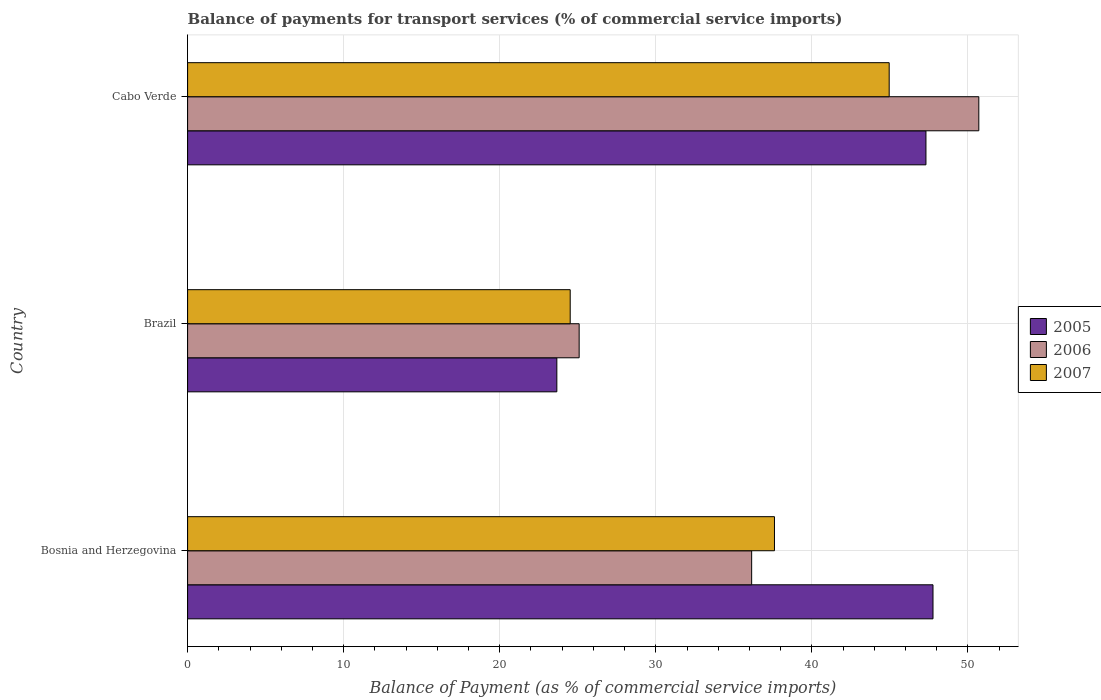How many different coloured bars are there?
Offer a very short reply. 3. Are the number of bars per tick equal to the number of legend labels?
Ensure brevity in your answer.  Yes. How many bars are there on the 2nd tick from the top?
Provide a succinct answer. 3. How many bars are there on the 1st tick from the bottom?
Keep it short and to the point. 3. What is the balance of payments for transport services in 2006 in Cabo Verde?
Provide a succinct answer. 50.7. Across all countries, what is the maximum balance of payments for transport services in 2005?
Give a very brief answer. 47.76. Across all countries, what is the minimum balance of payments for transport services in 2006?
Ensure brevity in your answer.  25.09. In which country was the balance of payments for transport services in 2006 maximum?
Keep it short and to the point. Cabo Verde. What is the total balance of payments for transport services in 2006 in the graph?
Your answer should be compact. 111.93. What is the difference between the balance of payments for transport services in 2006 in Brazil and that in Cabo Verde?
Your response must be concise. -25.61. What is the difference between the balance of payments for transport services in 2005 in Cabo Verde and the balance of payments for transport services in 2006 in Brazil?
Your answer should be compact. 22.22. What is the average balance of payments for transport services in 2007 per country?
Your answer should be compact. 35.69. What is the difference between the balance of payments for transport services in 2005 and balance of payments for transport services in 2006 in Bosnia and Herzegovina?
Your answer should be compact. 11.62. In how many countries, is the balance of payments for transport services in 2007 greater than 28 %?
Your answer should be very brief. 2. What is the ratio of the balance of payments for transport services in 2006 in Bosnia and Herzegovina to that in Cabo Verde?
Keep it short and to the point. 0.71. Is the balance of payments for transport services in 2006 in Bosnia and Herzegovina less than that in Cabo Verde?
Offer a very short reply. Yes. What is the difference between the highest and the second highest balance of payments for transport services in 2005?
Your answer should be compact. 0.45. What is the difference between the highest and the lowest balance of payments for transport services in 2006?
Offer a very short reply. 25.61. Is the sum of the balance of payments for transport services in 2005 in Brazil and Cabo Verde greater than the maximum balance of payments for transport services in 2006 across all countries?
Your answer should be compact. Yes. What does the 3rd bar from the top in Bosnia and Herzegovina represents?
Provide a succinct answer. 2005. What does the 1st bar from the bottom in Cabo Verde represents?
Keep it short and to the point. 2005. How many bars are there?
Your answer should be compact. 9. How many countries are there in the graph?
Offer a terse response. 3. Are the values on the major ticks of X-axis written in scientific E-notation?
Provide a short and direct response. No. Does the graph contain grids?
Ensure brevity in your answer.  Yes. Where does the legend appear in the graph?
Your answer should be compact. Center right. How many legend labels are there?
Provide a short and direct response. 3. How are the legend labels stacked?
Your answer should be compact. Vertical. What is the title of the graph?
Keep it short and to the point. Balance of payments for transport services (% of commercial service imports). Does "1968" appear as one of the legend labels in the graph?
Offer a terse response. No. What is the label or title of the X-axis?
Ensure brevity in your answer.  Balance of Payment (as % of commercial service imports). What is the label or title of the Y-axis?
Provide a short and direct response. Country. What is the Balance of Payment (as % of commercial service imports) of 2005 in Bosnia and Herzegovina?
Make the answer very short. 47.76. What is the Balance of Payment (as % of commercial service imports) in 2006 in Bosnia and Herzegovina?
Provide a succinct answer. 36.14. What is the Balance of Payment (as % of commercial service imports) in 2007 in Bosnia and Herzegovina?
Your answer should be very brief. 37.6. What is the Balance of Payment (as % of commercial service imports) in 2005 in Brazil?
Provide a succinct answer. 23.66. What is the Balance of Payment (as % of commercial service imports) of 2006 in Brazil?
Your response must be concise. 25.09. What is the Balance of Payment (as % of commercial service imports) in 2007 in Brazil?
Your answer should be very brief. 24.52. What is the Balance of Payment (as % of commercial service imports) in 2005 in Cabo Verde?
Ensure brevity in your answer.  47.31. What is the Balance of Payment (as % of commercial service imports) of 2006 in Cabo Verde?
Give a very brief answer. 50.7. What is the Balance of Payment (as % of commercial service imports) in 2007 in Cabo Verde?
Provide a short and direct response. 44.96. Across all countries, what is the maximum Balance of Payment (as % of commercial service imports) of 2005?
Provide a short and direct response. 47.76. Across all countries, what is the maximum Balance of Payment (as % of commercial service imports) of 2006?
Provide a succinct answer. 50.7. Across all countries, what is the maximum Balance of Payment (as % of commercial service imports) in 2007?
Your answer should be compact. 44.96. Across all countries, what is the minimum Balance of Payment (as % of commercial service imports) of 2005?
Give a very brief answer. 23.66. Across all countries, what is the minimum Balance of Payment (as % of commercial service imports) in 2006?
Your response must be concise. 25.09. Across all countries, what is the minimum Balance of Payment (as % of commercial service imports) of 2007?
Provide a succinct answer. 24.52. What is the total Balance of Payment (as % of commercial service imports) in 2005 in the graph?
Your answer should be compact. 118.73. What is the total Balance of Payment (as % of commercial service imports) of 2006 in the graph?
Your answer should be very brief. 111.93. What is the total Balance of Payment (as % of commercial service imports) of 2007 in the graph?
Your answer should be compact. 107.08. What is the difference between the Balance of Payment (as % of commercial service imports) in 2005 in Bosnia and Herzegovina and that in Brazil?
Your answer should be compact. 24.1. What is the difference between the Balance of Payment (as % of commercial service imports) of 2006 in Bosnia and Herzegovina and that in Brazil?
Ensure brevity in your answer.  11.05. What is the difference between the Balance of Payment (as % of commercial service imports) in 2007 in Bosnia and Herzegovina and that in Brazil?
Your answer should be very brief. 13.09. What is the difference between the Balance of Payment (as % of commercial service imports) in 2005 in Bosnia and Herzegovina and that in Cabo Verde?
Provide a succinct answer. 0.45. What is the difference between the Balance of Payment (as % of commercial service imports) of 2006 in Bosnia and Herzegovina and that in Cabo Verde?
Provide a short and direct response. -14.55. What is the difference between the Balance of Payment (as % of commercial service imports) in 2007 in Bosnia and Herzegovina and that in Cabo Verde?
Provide a short and direct response. -7.35. What is the difference between the Balance of Payment (as % of commercial service imports) in 2005 in Brazil and that in Cabo Verde?
Keep it short and to the point. -23.65. What is the difference between the Balance of Payment (as % of commercial service imports) in 2006 in Brazil and that in Cabo Verde?
Keep it short and to the point. -25.61. What is the difference between the Balance of Payment (as % of commercial service imports) of 2007 in Brazil and that in Cabo Verde?
Provide a succinct answer. -20.44. What is the difference between the Balance of Payment (as % of commercial service imports) in 2005 in Bosnia and Herzegovina and the Balance of Payment (as % of commercial service imports) in 2006 in Brazil?
Give a very brief answer. 22.67. What is the difference between the Balance of Payment (as % of commercial service imports) in 2005 in Bosnia and Herzegovina and the Balance of Payment (as % of commercial service imports) in 2007 in Brazil?
Keep it short and to the point. 23.25. What is the difference between the Balance of Payment (as % of commercial service imports) of 2006 in Bosnia and Herzegovina and the Balance of Payment (as % of commercial service imports) of 2007 in Brazil?
Ensure brevity in your answer.  11.63. What is the difference between the Balance of Payment (as % of commercial service imports) in 2005 in Bosnia and Herzegovina and the Balance of Payment (as % of commercial service imports) in 2006 in Cabo Verde?
Your answer should be compact. -2.94. What is the difference between the Balance of Payment (as % of commercial service imports) in 2005 in Bosnia and Herzegovina and the Balance of Payment (as % of commercial service imports) in 2007 in Cabo Verde?
Offer a very short reply. 2.81. What is the difference between the Balance of Payment (as % of commercial service imports) of 2006 in Bosnia and Herzegovina and the Balance of Payment (as % of commercial service imports) of 2007 in Cabo Verde?
Your answer should be compact. -8.81. What is the difference between the Balance of Payment (as % of commercial service imports) in 2005 in Brazil and the Balance of Payment (as % of commercial service imports) in 2006 in Cabo Verde?
Provide a short and direct response. -27.04. What is the difference between the Balance of Payment (as % of commercial service imports) in 2005 in Brazil and the Balance of Payment (as % of commercial service imports) in 2007 in Cabo Verde?
Provide a short and direct response. -21.3. What is the difference between the Balance of Payment (as % of commercial service imports) of 2006 in Brazil and the Balance of Payment (as % of commercial service imports) of 2007 in Cabo Verde?
Make the answer very short. -19.87. What is the average Balance of Payment (as % of commercial service imports) in 2005 per country?
Give a very brief answer. 39.58. What is the average Balance of Payment (as % of commercial service imports) of 2006 per country?
Offer a terse response. 37.31. What is the average Balance of Payment (as % of commercial service imports) of 2007 per country?
Provide a short and direct response. 35.69. What is the difference between the Balance of Payment (as % of commercial service imports) in 2005 and Balance of Payment (as % of commercial service imports) in 2006 in Bosnia and Herzegovina?
Your answer should be compact. 11.62. What is the difference between the Balance of Payment (as % of commercial service imports) of 2005 and Balance of Payment (as % of commercial service imports) of 2007 in Bosnia and Herzegovina?
Offer a very short reply. 10.16. What is the difference between the Balance of Payment (as % of commercial service imports) in 2006 and Balance of Payment (as % of commercial service imports) in 2007 in Bosnia and Herzegovina?
Provide a succinct answer. -1.46. What is the difference between the Balance of Payment (as % of commercial service imports) in 2005 and Balance of Payment (as % of commercial service imports) in 2006 in Brazil?
Give a very brief answer. -1.43. What is the difference between the Balance of Payment (as % of commercial service imports) in 2005 and Balance of Payment (as % of commercial service imports) in 2007 in Brazil?
Your answer should be very brief. -0.86. What is the difference between the Balance of Payment (as % of commercial service imports) in 2006 and Balance of Payment (as % of commercial service imports) in 2007 in Brazil?
Give a very brief answer. 0.57. What is the difference between the Balance of Payment (as % of commercial service imports) in 2005 and Balance of Payment (as % of commercial service imports) in 2006 in Cabo Verde?
Ensure brevity in your answer.  -3.39. What is the difference between the Balance of Payment (as % of commercial service imports) in 2005 and Balance of Payment (as % of commercial service imports) in 2007 in Cabo Verde?
Ensure brevity in your answer.  2.36. What is the difference between the Balance of Payment (as % of commercial service imports) of 2006 and Balance of Payment (as % of commercial service imports) of 2007 in Cabo Verde?
Give a very brief answer. 5.74. What is the ratio of the Balance of Payment (as % of commercial service imports) of 2005 in Bosnia and Herzegovina to that in Brazil?
Give a very brief answer. 2.02. What is the ratio of the Balance of Payment (as % of commercial service imports) of 2006 in Bosnia and Herzegovina to that in Brazil?
Your response must be concise. 1.44. What is the ratio of the Balance of Payment (as % of commercial service imports) of 2007 in Bosnia and Herzegovina to that in Brazil?
Make the answer very short. 1.53. What is the ratio of the Balance of Payment (as % of commercial service imports) of 2005 in Bosnia and Herzegovina to that in Cabo Verde?
Keep it short and to the point. 1.01. What is the ratio of the Balance of Payment (as % of commercial service imports) in 2006 in Bosnia and Herzegovina to that in Cabo Verde?
Provide a succinct answer. 0.71. What is the ratio of the Balance of Payment (as % of commercial service imports) in 2007 in Bosnia and Herzegovina to that in Cabo Verde?
Offer a terse response. 0.84. What is the ratio of the Balance of Payment (as % of commercial service imports) in 2005 in Brazil to that in Cabo Verde?
Your answer should be very brief. 0.5. What is the ratio of the Balance of Payment (as % of commercial service imports) in 2006 in Brazil to that in Cabo Verde?
Keep it short and to the point. 0.49. What is the ratio of the Balance of Payment (as % of commercial service imports) of 2007 in Brazil to that in Cabo Verde?
Your answer should be very brief. 0.55. What is the difference between the highest and the second highest Balance of Payment (as % of commercial service imports) of 2005?
Offer a very short reply. 0.45. What is the difference between the highest and the second highest Balance of Payment (as % of commercial service imports) in 2006?
Provide a short and direct response. 14.55. What is the difference between the highest and the second highest Balance of Payment (as % of commercial service imports) in 2007?
Make the answer very short. 7.35. What is the difference between the highest and the lowest Balance of Payment (as % of commercial service imports) in 2005?
Offer a very short reply. 24.1. What is the difference between the highest and the lowest Balance of Payment (as % of commercial service imports) of 2006?
Your answer should be very brief. 25.61. What is the difference between the highest and the lowest Balance of Payment (as % of commercial service imports) in 2007?
Provide a succinct answer. 20.44. 